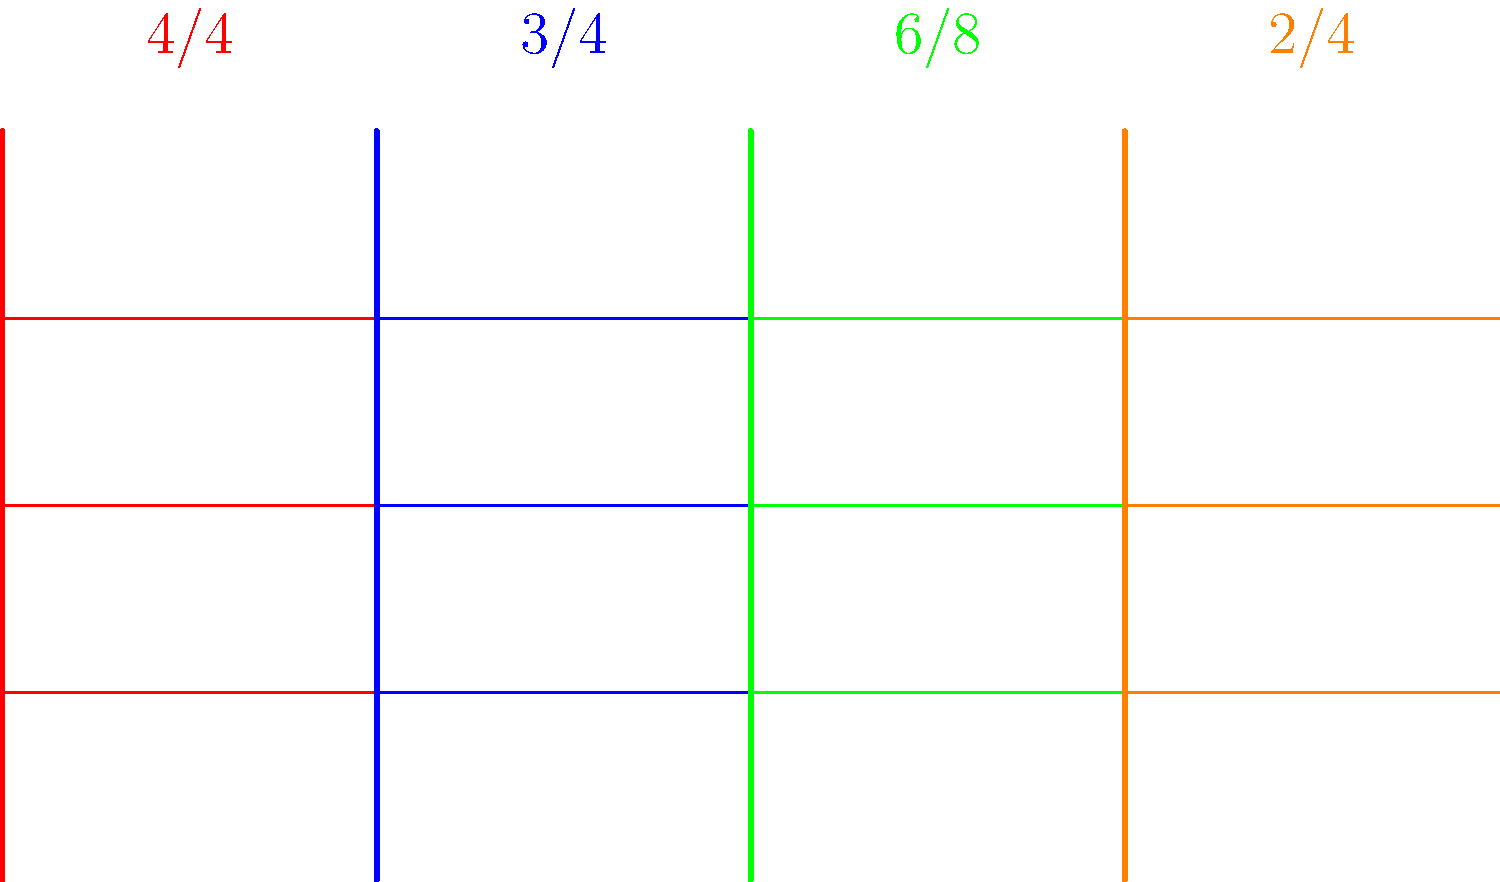As a drummer, you're often required to quickly identify time signatures. In the image above, which color represents the time signature commonly used in most pop and rock songs, often referred to as "common time"? Let's analyze each time signature in the image:

1. Red represents 4/4 time
2. Blue represents 3/4 time
3. Green represents 6/8 time
4. Orange represents 2/4 time

As a drummer in a boy band, you should be very familiar with 4/4 time, also known as "common time." This time signature is used in the vast majority of pop and rock songs due to its steady, four-beat rhythm that's easy to dance to.

4/4 time means there are four beats in each measure, and each beat is represented by a quarter note. This creates a strong, consistent rhythm that's perfect for popular music genres.

In the image, 4/4 time is represented by the red lines and label.
Answer: Red 